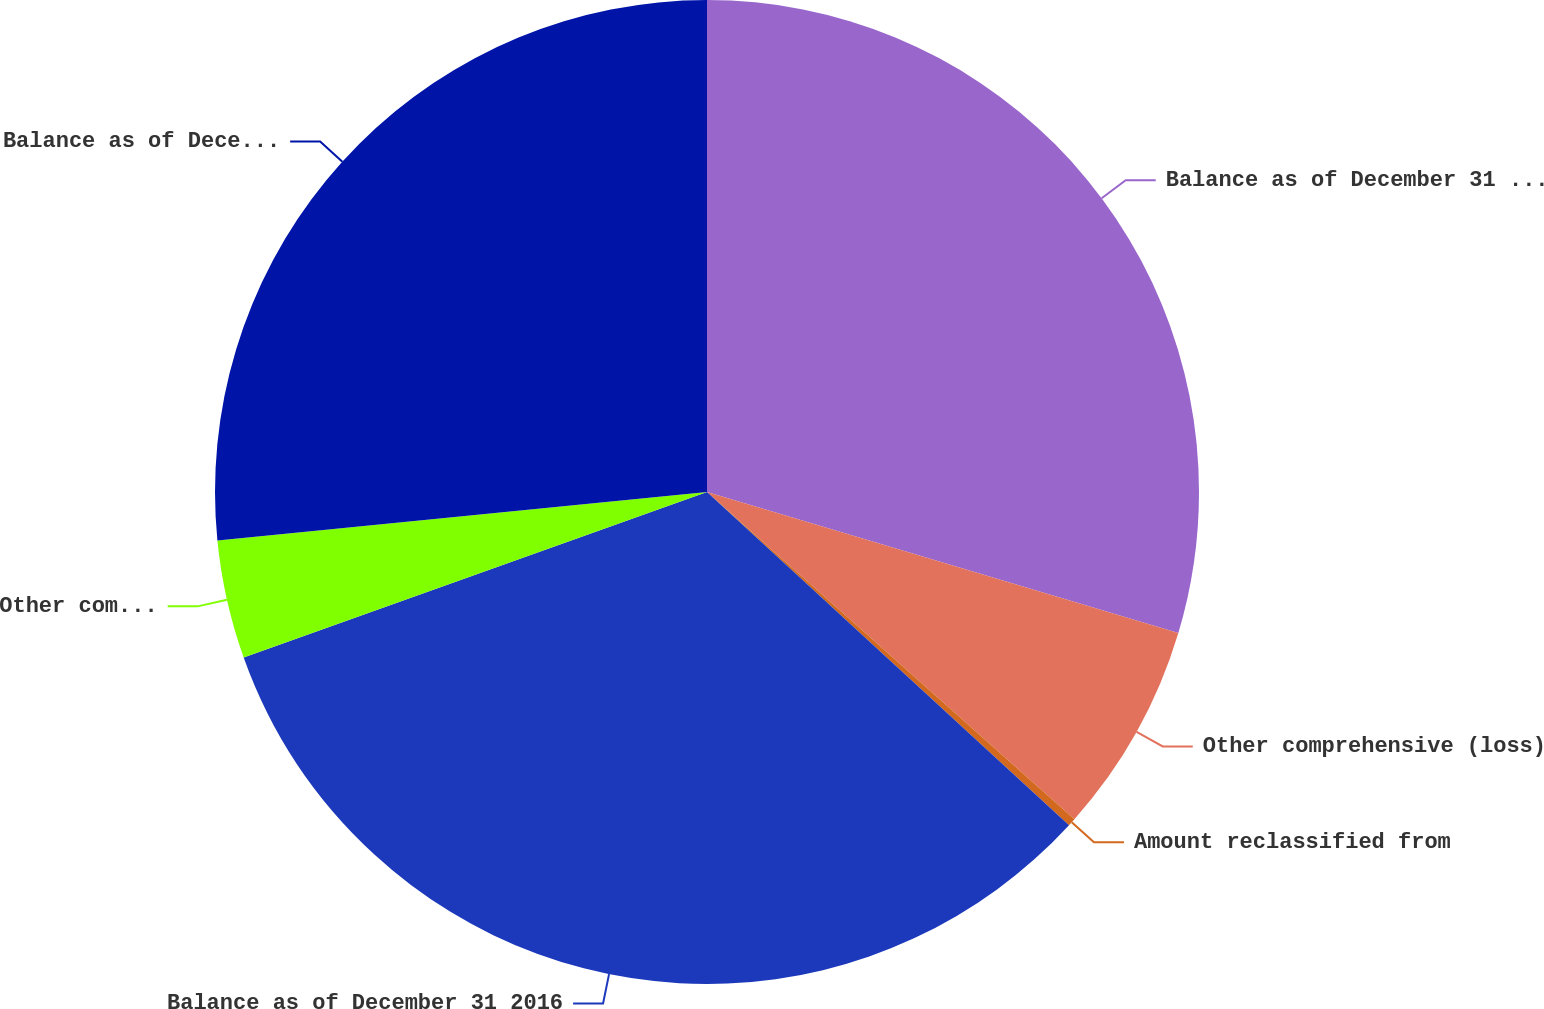Convert chart. <chart><loc_0><loc_0><loc_500><loc_500><pie_chart><fcel>Balance as of December 31 2015<fcel>Other comprehensive (loss)<fcel>Amount reclassified from<fcel>Balance as of December 31 2016<fcel>Other comprehensive income<fcel>Balance as of December 31 2017<nl><fcel>29.63%<fcel>6.95%<fcel>0.26%<fcel>32.7%<fcel>3.89%<fcel>26.57%<nl></chart> 